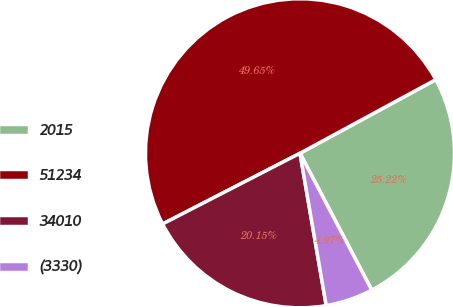Convert chart. <chart><loc_0><loc_0><loc_500><loc_500><pie_chart><fcel>2015<fcel>51234<fcel>34010<fcel>(3330)<nl><fcel>25.22%<fcel>49.65%<fcel>20.15%<fcel>4.97%<nl></chart> 